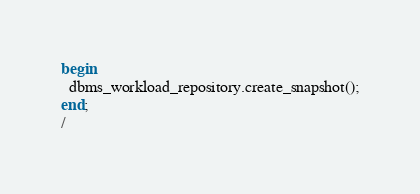<code> <loc_0><loc_0><loc_500><loc_500><_SQL_>begin
  dbms_workload_repository.create_snapshot();
end;
/
</code> 